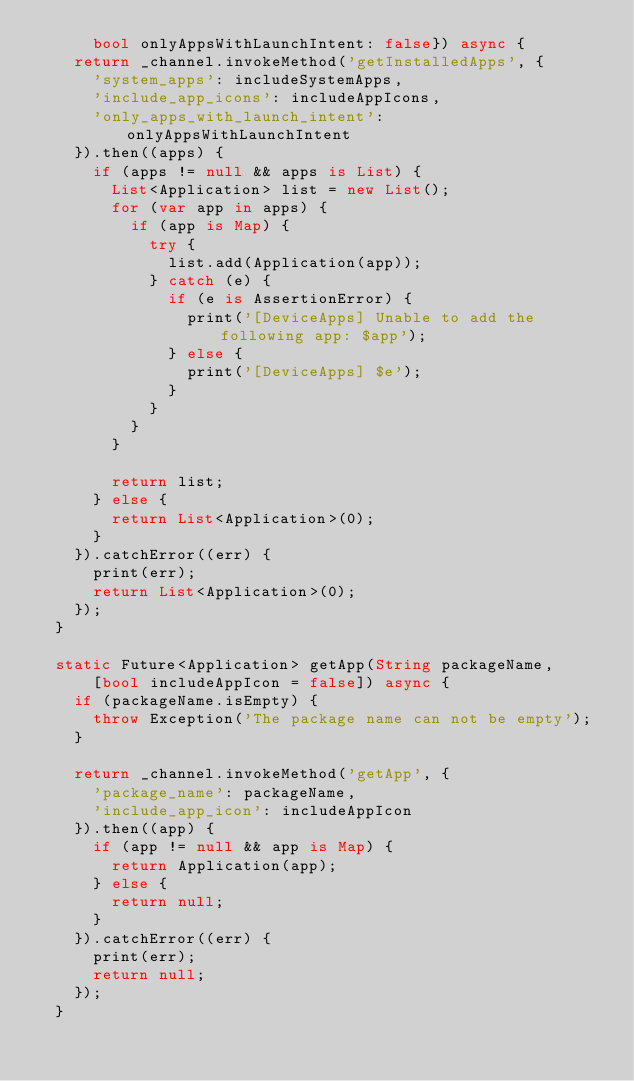<code> <loc_0><loc_0><loc_500><loc_500><_Dart_>      bool onlyAppsWithLaunchIntent: false}) async {
    return _channel.invokeMethod('getInstalledApps', {
      'system_apps': includeSystemApps,
      'include_app_icons': includeAppIcons,
      'only_apps_with_launch_intent': onlyAppsWithLaunchIntent
    }).then((apps) {
      if (apps != null && apps is List) {
        List<Application> list = new List();
        for (var app in apps) {
          if (app is Map) {
            try {
              list.add(Application(app));
            } catch (e) {
              if (e is AssertionError) {
                print('[DeviceApps] Unable to add the following app: $app');
              } else {
                print('[DeviceApps] $e');
              }
            }
          }
        }

        return list;
      } else {
        return List<Application>(0);
      }
    }).catchError((err) {
      print(err);
      return List<Application>(0);
    });
  }

  static Future<Application> getApp(String packageName,
      [bool includeAppIcon = false]) async {
    if (packageName.isEmpty) {
      throw Exception('The package name can not be empty');
    }

    return _channel.invokeMethod('getApp', {
      'package_name': packageName,
      'include_app_icon': includeAppIcon
    }).then((app) {
      if (app != null && app is Map) {
        return Application(app);
      } else {
        return null;
      }
    }).catchError((err) {
      print(err);
      return null;
    });
  }
</code> 